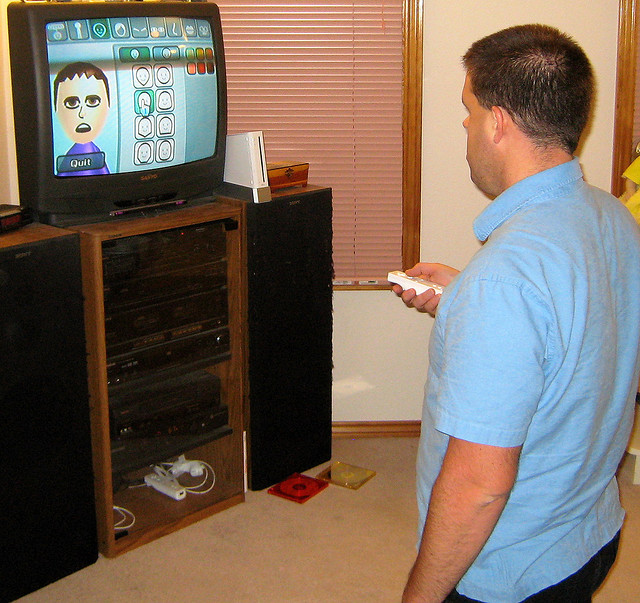Please transcribe the text information in this image. Quit 